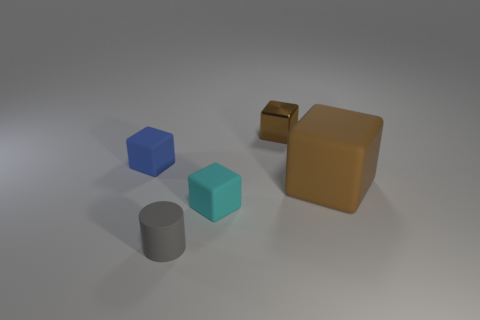Add 5 large gray matte balls. How many objects exist? 10 Subtract all cylinders. How many objects are left? 4 Add 2 cyan things. How many cyan things are left? 3 Add 3 large brown rubber things. How many large brown rubber things exist? 4 Subtract 0 blue spheres. How many objects are left? 5 Subtract all matte cubes. Subtract all brown matte cubes. How many objects are left? 1 